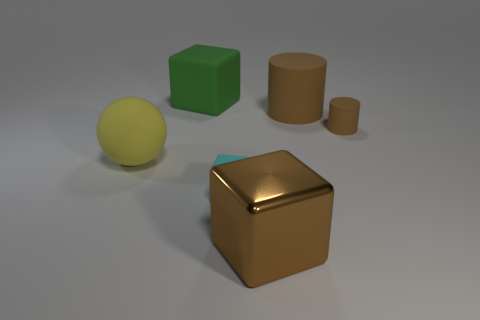Subtract all large blocks. How many blocks are left? 1 Add 2 rubber balls. How many objects exist? 8 Subtract all spheres. How many objects are left? 5 Subtract 0 green spheres. How many objects are left? 6 Subtract all big brown matte objects. Subtract all gray metallic cylinders. How many objects are left? 5 Add 5 green blocks. How many green blocks are left? 6 Add 5 matte balls. How many matte balls exist? 6 